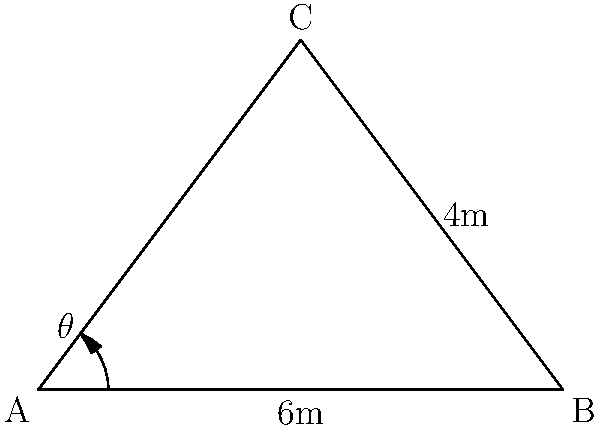Your eco-conscious neighbor is teaching you about composting. She explains that the angle of the compost pile is crucial for proper aeration and decomposition. The base of her triangular compost pile is 6 meters wide, and the height at the center is 4 meters. What is the angle $\theta$ (in degrees) between the side of the pile and the ground? To find the angle $\theta$, we can use trigonometry in the right triangle formed by half of the compost pile:

1. The base of this right triangle is half of the total width: $6 \div 2 = 3$ meters.
2. The height of the triangle is given as 4 meters.
3. We can use the tangent function to find the angle:

   $\tan(\theta) = \frac{\text{opposite}}{\text{adjacent}} = \frac{4}{3}$

4. To solve for $\theta$, we need to use the inverse tangent (arctangent) function:

   $\theta = \arctan(\frac{4}{3})$

5. Using a calculator or computer:

   $\theta \approx 53.13010235415598$ degrees

6. Rounding to two decimal places:

   $\theta \approx 53.13$ degrees

This angle ensures proper aeration and optimal decomposition conditions for the compost pile.
Answer: $53.13^{\circ}$ 